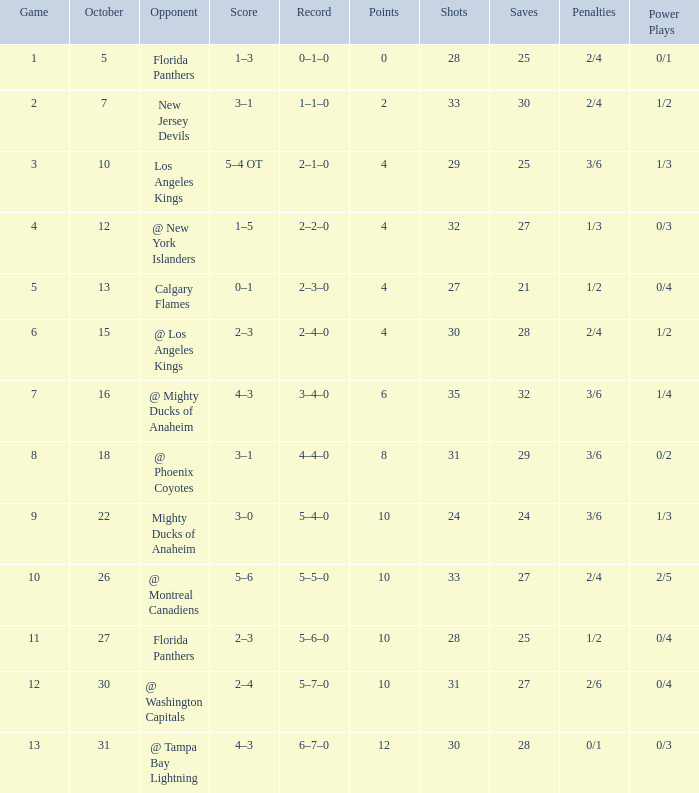What team has a score of 11 5–6–0. 